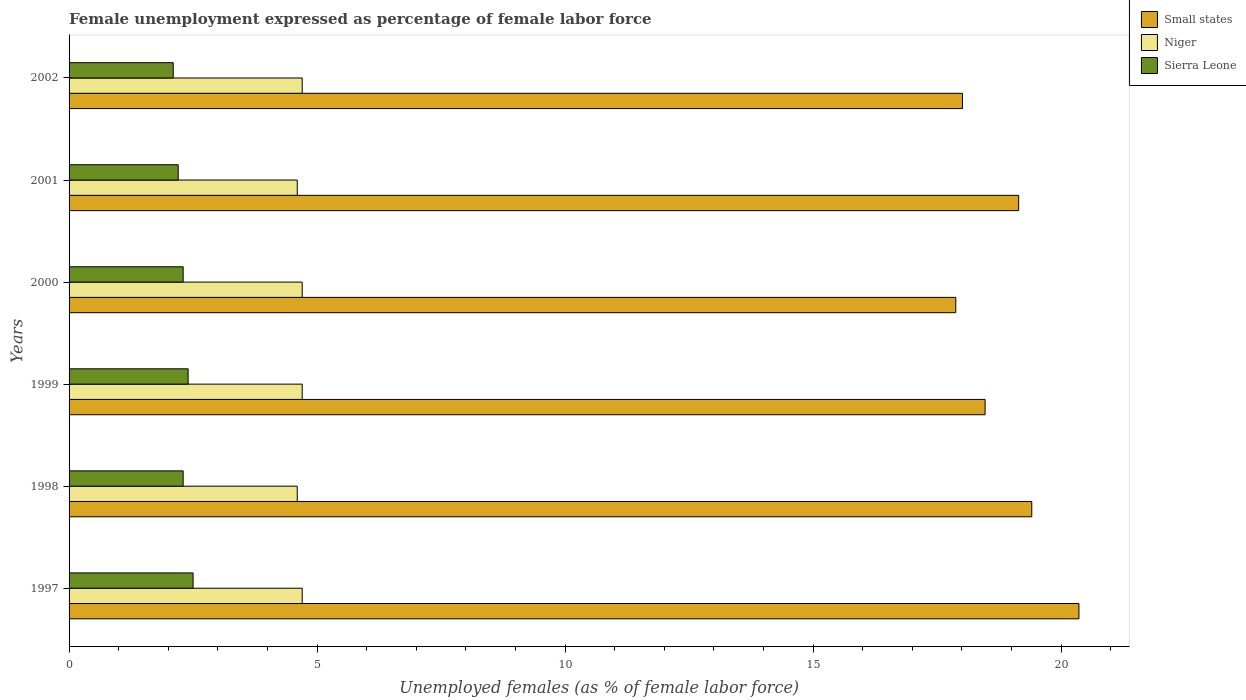How many different coloured bars are there?
Offer a very short reply. 3. Are the number of bars per tick equal to the number of legend labels?
Your answer should be very brief. Yes. How many bars are there on the 6th tick from the bottom?
Your answer should be compact. 3. What is the label of the 2nd group of bars from the top?
Make the answer very short. 2001. In how many cases, is the number of bars for a given year not equal to the number of legend labels?
Offer a terse response. 0. What is the unemployment in females in in Niger in 2000?
Give a very brief answer. 4.7. Across all years, what is the minimum unemployment in females in in Sierra Leone?
Make the answer very short. 2.1. In which year was the unemployment in females in in Niger minimum?
Ensure brevity in your answer.  1998. What is the total unemployment in females in in Small states in the graph?
Give a very brief answer. 113.26. What is the difference between the unemployment in females in in Small states in 1998 and that in 2001?
Provide a succinct answer. 0.26. What is the difference between the unemployment in females in in Niger in 1997 and the unemployment in females in in Small states in 2002?
Your response must be concise. -13.31. What is the average unemployment in females in in Small states per year?
Your answer should be compact. 18.88. In the year 1999, what is the difference between the unemployment in females in in Sierra Leone and unemployment in females in in Small states?
Your answer should be very brief. -16.07. In how many years, is the unemployment in females in in Niger greater than 15 %?
Offer a very short reply. 0. What is the ratio of the unemployment in females in in Small states in 1998 to that in 1999?
Your answer should be compact. 1.05. Is the unemployment in females in in Niger in 1998 less than that in 2002?
Ensure brevity in your answer.  Yes. What is the difference between the highest and the second highest unemployment in females in in Sierra Leone?
Offer a terse response. 0.1. What is the difference between the highest and the lowest unemployment in females in in Small states?
Offer a very short reply. 2.48. In how many years, is the unemployment in females in in Sierra Leone greater than the average unemployment in females in in Sierra Leone taken over all years?
Ensure brevity in your answer.  2. Is the sum of the unemployment in females in in Small states in 1997 and 2001 greater than the maximum unemployment in females in in Sierra Leone across all years?
Your answer should be very brief. Yes. What does the 1st bar from the top in 1998 represents?
Offer a terse response. Sierra Leone. What does the 1st bar from the bottom in 2000 represents?
Provide a succinct answer. Small states. How many bars are there?
Ensure brevity in your answer.  18. Are all the bars in the graph horizontal?
Provide a succinct answer. Yes. How many years are there in the graph?
Give a very brief answer. 6. Does the graph contain any zero values?
Your response must be concise. No. Where does the legend appear in the graph?
Your answer should be very brief. Top right. What is the title of the graph?
Ensure brevity in your answer.  Female unemployment expressed as percentage of female labor force. Does "Central Europe" appear as one of the legend labels in the graph?
Your answer should be compact. No. What is the label or title of the X-axis?
Provide a short and direct response. Unemployed females (as % of female labor force). What is the label or title of the Y-axis?
Ensure brevity in your answer.  Years. What is the Unemployed females (as % of female labor force) in Small states in 1997?
Offer a very short reply. 20.36. What is the Unemployed females (as % of female labor force) in Niger in 1997?
Keep it short and to the point. 4.7. What is the Unemployed females (as % of female labor force) of Sierra Leone in 1997?
Your answer should be very brief. 2.5. What is the Unemployed females (as % of female labor force) in Small states in 1998?
Give a very brief answer. 19.41. What is the Unemployed females (as % of female labor force) in Niger in 1998?
Provide a short and direct response. 4.6. What is the Unemployed females (as % of female labor force) of Sierra Leone in 1998?
Your answer should be compact. 2.3. What is the Unemployed females (as % of female labor force) in Small states in 1999?
Provide a succinct answer. 18.47. What is the Unemployed females (as % of female labor force) of Niger in 1999?
Your answer should be compact. 4.7. What is the Unemployed females (as % of female labor force) of Sierra Leone in 1999?
Ensure brevity in your answer.  2.4. What is the Unemployed females (as % of female labor force) in Small states in 2000?
Provide a short and direct response. 17.88. What is the Unemployed females (as % of female labor force) in Niger in 2000?
Keep it short and to the point. 4.7. What is the Unemployed females (as % of female labor force) in Sierra Leone in 2000?
Your answer should be compact. 2.3. What is the Unemployed females (as % of female labor force) of Small states in 2001?
Keep it short and to the point. 19.14. What is the Unemployed females (as % of female labor force) in Niger in 2001?
Your response must be concise. 4.6. What is the Unemployed females (as % of female labor force) in Sierra Leone in 2001?
Make the answer very short. 2.2. What is the Unemployed females (as % of female labor force) of Small states in 2002?
Ensure brevity in your answer.  18.01. What is the Unemployed females (as % of female labor force) of Niger in 2002?
Offer a terse response. 4.7. What is the Unemployed females (as % of female labor force) of Sierra Leone in 2002?
Your answer should be compact. 2.1. Across all years, what is the maximum Unemployed females (as % of female labor force) in Small states?
Offer a terse response. 20.36. Across all years, what is the maximum Unemployed females (as % of female labor force) in Niger?
Make the answer very short. 4.7. Across all years, what is the maximum Unemployed females (as % of female labor force) in Sierra Leone?
Provide a succinct answer. 2.5. Across all years, what is the minimum Unemployed females (as % of female labor force) of Small states?
Provide a succinct answer. 17.88. Across all years, what is the minimum Unemployed females (as % of female labor force) in Niger?
Give a very brief answer. 4.6. Across all years, what is the minimum Unemployed females (as % of female labor force) of Sierra Leone?
Offer a very short reply. 2.1. What is the total Unemployed females (as % of female labor force) of Small states in the graph?
Your response must be concise. 113.26. What is the total Unemployed females (as % of female labor force) of Niger in the graph?
Your answer should be very brief. 28. What is the total Unemployed females (as % of female labor force) of Sierra Leone in the graph?
Provide a succinct answer. 13.8. What is the difference between the Unemployed females (as % of female labor force) in Small states in 1997 and that in 1998?
Give a very brief answer. 0.95. What is the difference between the Unemployed females (as % of female labor force) of Sierra Leone in 1997 and that in 1998?
Keep it short and to the point. 0.2. What is the difference between the Unemployed females (as % of female labor force) in Small states in 1997 and that in 1999?
Give a very brief answer. 1.89. What is the difference between the Unemployed females (as % of female labor force) of Sierra Leone in 1997 and that in 1999?
Ensure brevity in your answer.  0.1. What is the difference between the Unemployed females (as % of female labor force) of Small states in 1997 and that in 2000?
Your response must be concise. 2.48. What is the difference between the Unemployed females (as % of female labor force) in Niger in 1997 and that in 2000?
Offer a terse response. 0. What is the difference between the Unemployed females (as % of female labor force) in Small states in 1997 and that in 2001?
Give a very brief answer. 1.22. What is the difference between the Unemployed females (as % of female labor force) of Niger in 1997 and that in 2001?
Keep it short and to the point. 0.1. What is the difference between the Unemployed females (as % of female labor force) in Sierra Leone in 1997 and that in 2001?
Your answer should be compact. 0.3. What is the difference between the Unemployed females (as % of female labor force) of Small states in 1997 and that in 2002?
Offer a terse response. 2.35. What is the difference between the Unemployed females (as % of female labor force) of Niger in 1997 and that in 2002?
Provide a short and direct response. 0. What is the difference between the Unemployed females (as % of female labor force) in Sierra Leone in 1997 and that in 2002?
Keep it short and to the point. 0.4. What is the difference between the Unemployed females (as % of female labor force) in Small states in 1998 and that in 1999?
Your response must be concise. 0.94. What is the difference between the Unemployed females (as % of female labor force) of Niger in 1998 and that in 1999?
Ensure brevity in your answer.  -0.1. What is the difference between the Unemployed females (as % of female labor force) in Sierra Leone in 1998 and that in 1999?
Offer a terse response. -0.1. What is the difference between the Unemployed females (as % of female labor force) in Small states in 1998 and that in 2000?
Offer a very short reply. 1.53. What is the difference between the Unemployed females (as % of female labor force) in Sierra Leone in 1998 and that in 2000?
Your answer should be very brief. 0. What is the difference between the Unemployed females (as % of female labor force) of Small states in 1998 and that in 2001?
Your answer should be compact. 0.26. What is the difference between the Unemployed females (as % of female labor force) in Niger in 1998 and that in 2001?
Keep it short and to the point. 0. What is the difference between the Unemployed females (as % of female labor force) of Small states in 1998 and that in 2002?
Offer a very short reply. 1.4. What is the difference between the Unemployed females (as % of female labor force) of Small states in 1999 and that in 2000?
Offer a terse response. 0.59. What is the difference between the Unemployed females (as % of female labor force) of Niger in 1999 and that in 2000?
Give a very brief answer. 0. What is the difference between the Unemployed females (as % of female labor force) of Sierra Leone in 1999 and that in 2000?
Ensure brevity in your answer.  0.1. What is the difference between the Unemployed females (as % of female labor force) of Small states in 1999 and that in 2001?
Ensure brevity in your answer.  -0.68. What is the difference between the Unemployed females (as % of female labor force) in Sierra Leone in 1999 and that in 2001?
Make the answer very short. 0.2. What is the difference between the Unemployed females (as % of female labor force) in Small states in 1999 and that in 2002?
Your answer should be very brief. 0.46. What is the difference between the Unemployed females (as % of female labor force) of Small states in 2000 and that in 2001?
Provide a short and direct response. -1.27. What is the difference between the Unemployed females (as % of female labor force) of Sierra Leone in 2000 and that in 2001?
Give a very brief answer. 0.1. What is the difference between the Unemployed females (as % of female labor force) in Small states in 2000 and that in 2002?
Keep it short and to the point. -0.14. What is the difference between the Unemployed females (as % of female labor force) in Sierra Leone in 2000 and that in 2002?
Your response must be concise. 0.2. What is the difference between the Unemployed females (as % of female labor force) in Small states in 2001 and that in 2002?
Your response must be concise. 1.13. What is the difference between the Unemployed females (as % of female labor force) in Sierra Leone in 2001 and that in 2002?
Give a very brief answer. 0.1. What is the difference between the Unemployed females (as % of female labor force) in Small states in 1997 and the Unemployed females (as % of female labor force) in Niger in 1998?
Give a very brief answer. 15.76. What is the difference between the Unemployed females (as % of female labor force) of Small states in 1997 and the Unemployed females (as % of female labor force) of Sierra Leone in 1998?
Provide a succinct answer. 18.06. What is the difference between the Unemployed females (as % of female labor force) of Small states in 1997 and the Unemployed females (as % of female labor force) of Niger in 1999?
Provide a succinct answer. 15.66. What is the difference between the Unemployed females (as % of female labor force) in Small states in 1997 and the Unemployed females (as % of female labor force) in Sierra Leone in 1999?
Your answer should be compact. 17.96. What is the difference between the Unemployed females (as % of female labor force) in Niger in 1997 and the Unemployed females (as % of female labor force) in Sierra Leone in 1999?
Your response must be concise. 2.3. What is the difference between the Unemployed females (as % of female labor force) of Small states in 1997 and the Unemployed females (as % of female labor force) of Niger in 2000?
Offer a terse response. 15.66. What is the difference between the Unemployed females (as % of female labor force) in Small states in 1997 and the Unemployed females (as % of female labor force) in Sierra Leone in 2000?
Provide a succinct answer. 18.06. What is the difference between the Unemployed females (as % of female labor force) of Niger in 1997 and the Unemployed females (as % of female labor force) of Sierra Leone in 2000?
Keep it short and to the point. 2.4. What is the difference between the Unemployed females (as % of female labor force) of Small states in 1997 and the Unemployed females (as % of female labor force) of Niger in 2001?
Your response must be concise. 15.76. What is the difference between the Unemployed females (as % of female labor force) in Small states in 1997 and the Unemployed females (as % of female labor force) in Sierra Leone in 2001?
Provide a short and direct response. 18.16. What is the difference between the Unemployed females (as % of female labor force) in Niger in 1997 and the Unemployed females (as % of female labor force) in Sierra Leone in 2001?
Provide a short and direct response. 2.5. What is the difference between the Unemployed females (as % of female labor force) in Small states in 1997 and the Unemployed females (as % of female labor force) in Niger in 2002?
Provide a succinct answer. 15.66. What is the difference between the Unemployed females (as % of female labor force) in Small states in 1997 and the Unemployed females (as % of female labor force) in Sierra Leone in 2002?
Give a very brief answer. 18.26. What is the difference between the Unemployed females (as % of female labor force) of Niger in 1997 and the Unemployed females (as % of female labor force) of Sierra Leone in 2002?
Your response must be concise. 2.6. What is the difference between the Unemployed females (as % of female labor force) in Small states in 1998 and the Unemployed females (as % of female labor force) in Niger in 1999?
Your answer should be compact. 14.71. What is the difference between the Unemployed females (as % of female labor force) of Small states in 1998 and the Unemployed females (as % of female labor force) of Sierra Leone in 1999?
Your answer should be compact. 17.01. What is the difference between the Unemployed females (as % of female labor force) of Niger in 1998 and the Unemployed females (as % of female labor force) of Sierra Leone in 1999?
Offer a very short reply. 2.2. What is the difference between the Unemployed females (as % of female labor force) in Small states in 1998 and the Unemployed females (as % of female labor force) in Niger in 2000?
Your response must be concise. 14.71. What is the difference between the Unemployed females (as % of female labor force) of Small states in 1998 and the Unemployed females (as % of female labor force) of Sierra Leone in 2000?
Make the answer very short. 17.11. What is the difference between the Unemployed females (as % of female labor force) of Small states in 1998 and the Unemployed females (as % of female labor force) of Niger in 2001?
Offer a terse response. 14.81. What is the difference between the Unemployed females (as % of female labor force) in Small states in 1998 and the Unemployed females (as % of female labor force) in Sierra Leone in 2001?
Your answer should be compact. 17.21. What is the difference between the Unemployed females (as % of female labor force) of Small states in 1998 and the Unemployed females (as % of female labor force) of Niger in 2002?
Your answer should be compact. 14.71. What is the difference between the Unemployed females (as % of female labor force) of Small states in 1998 and the Unemployed females (as % of female labor force) of Sierra Leone in 2002?
Your answer should be compact. 17.31. What is the difference between the Unemployed females (as % of female labor force) of Niger in 1998 and the Unemployed females (as % of female labor force) of Sierra Leone in 2002?
Give a very brief answer. 2.5. What is the difference between the Unemployed females (as % of female labor force) of Small states in 1999 and the Unemployed females (as % of female labor force) of Niger in 2000?
Ensure brevity in your answer.  13.77. What is the difference between the Unemployed females (as % of female labor force) in Small states in 1999 and the Unemployed females (as % of female labor force) in Sierra Leone in 2000?
Make the answer very short. 16.17. What is the difference between the Unemployed females (as % of female labor force) in Niger in 1999 and the Unemployed females (as % of female labor force) in Sierra Leone in 2000?
Provide a succinct answer. 2.4. What is the difference between the Unemployed females (as % of female labor force) in Small states in 1999 and the Unemployed females (as % of female labor force) in Niger in 2001?
Ensure brevity in your answer.  13.87. What is the difference between the Unemployed females (as % of female labor force) in Small states in 1999 and the Unemployed females (as % of female labor force) in Sierra Leone in 2001?
Your response must be concise. 16.27. What is the difference between the Unemployed females (as % of female labor force) in Small states in 1999 and the Unemployed females (as % of female labor force) in Niger in 2002?
Your answer should be compact. 13.77. What is the difference between the Unemployed females (as % of female labor force) in Small states in 1999 and the Unemployed females (as % of female labor force) in Sierra Leone in 2002?
Ensure brevity in your answer.  16.37. What is the difference between the Unemployed females (as % of female labor force) of Small states in 2000 and the Unemployed females (as % of female labor force) of Niger in 2001?
Make the answer very short. 13.28. What is the difference between the Unemployed females (as % of female labor force) in Small states in 2000 and the Unemployed females (as % of female labor force) in Sierra Leone in 2001?
Offer a terse response. 15.68. What is the difference between the Unemployed females (as % of female labor force) of Niger in 2000 and the Unemployed females (as % of female labor force) of Sierra Leone in 2001?
Keep it short and to the point. 2.5. What is the difference between the Unemployed females (as % of female labor force) in Small states in 2000 and the Unemployed females (as % of female labor force) in Niger in 2002?
Offer a very short reply. 13.18. What is the difference between the Unemployed females (as % of female labor force) of Small states in 2000 and the Unemployed females (as % of female labor force) of Sierra Leone in 2002?
Your answer should be compact. 15.78. What is the difference between the Unemployed females (as % of female labor force) in Niger in 2000 and the Unemployed females (as % of female labor force) in Sierra Leone in 2002?
Ensure brevity in your answer.  2.6. What is the difference between the Unemployed females (as % of female labor force) in Small states in 2001 and the Unemployed females (as % of female labor force) in Niger in 2002?
Provide a short and direct response. 14.44. What is the difference between the Unemployed females (as % of female labor force) of Small states in 2001 and the Unemployed females (as % of female labor force) of Sierra Leone in 2002?
Provide a short and direct response. 17.04. What is the difference between the Unemployed females (as % of female labor force) in Niger in 2001 and the Unemployed females (as % of female labor force) in Sierra Leone in 2002?
Ensure brevity in your answer.  2.5. What is the average Unemployed females (as % of female labor force) of Small states per year?
Your response must be concise. 18.88. What is the average Unemployed females (as % of female labor force) in Niger per year?
Your response must be concise. 4.67. In the year 1997, what is the difference between the Unemployed females (as % of female labor force) of Small states and Unemployed females (as % of female labor force) of Niger?
Offer a terse response. 15.66. In the year 1997, what is the difference between the Unemployed females (as % of female labor force) of Small states and Unemployed females (as % of female labor force) of Sierra Leone?
Make the answer very short. 17.86. In the year 1998, what is the difference between the Unemployed females (as % of female labor force) in Small states and Unemployed females (as % of female labor force) in Niger?
Your answer should be compact. 14.81. In the year 1998, what is the difference between the Unemployed females (as % of female labor force) of Small states and Unemployed females (as % of female labor force) of Sierra Leone?
Your answer should be very brief. 17.11. In the year 1999, what is the difference between the Unemployed females (as % of female labor force) of Small states and Unemployed females (as % of female labor force) of Niger?
Your answer should be very brief. 13.77. In the year 1999, what is the difference between the Unemployed females (as % of female labor force) in Small states and Unemployed females (as % of female labor force) in Sierra Leone?
Offer a terse response. 16.07. In the year 1999, what is the difference between the Unemployed females (as % of female labor force) of Niger and Unemployed females (as % of female labor force) of Sierra Leone?
Provide a succinct answer. 2.3. In the year 2000, what is the difference between the Unemployed females (as % of female labor force) of Small states and Unemployed females (as % of female labor force) of Niger?
Your answer should be very brief. 13.18. In the year 2000, what is the difference between the Unemployed females (as % of female labor force) in Small states and Unemployed females (as % of female labor force) in Sierra Leone?
Offer a terse response. 15.58. In the year 2001, what is the difference between the Unemployed females (as % of female labor force) in Small states and Unemployed females (as % of female labor force) in Niger?
Offer a very short reply. 14.54. In the year 2001, what is the difference between the Unemployed females (as % of female labor force) in Small states and Unemployed females (as % of female labor force) in Sierra Leone?
Your answer should be compact. 16.94. In the year 2002, what is the difference between the Unemployed females (as % of female labor force) of Small states and Unemployed females (as % of female labor force) of Niger?
Offer a terse response. 13.31. In the year 2002, what is the difference between the Unemployed females (as % of female labor force) in Small states and Unemployed females (as % of female labor force) in Sierra Leone?
Provide a short and direct response. 15.91. What is the ratio of the Unemployed females (as % of female labor force) of Small states in 1997 to that in 1998?
Give a very brief answer. 1.05. What is the ratio of the Unemployed females (as % of female labor force) in Niger in 1997 to that in 1998?
Make the answer very short. 1.02. What is the ratio of the Unemployed females (as % of female labor force) in Sierra Leone in 1997 to that in 1998?
Keep it short and to the point. 1.09. What is the ratio of the Unemployed females (as % of female labor force) in Small states in 1997 to that in 1999?
Keep it short and to the point. 1.1. What is the ratio of the Unemployed females (as % of female labor force) of Niger in 1997 to that in 1999?
Give a very brief answer. 1. What is the ratio of the Unemployed females (as % of female labor force) in Sierra Leone in 1997 to that in 1999?
Your answer should be compact. 1.04. What is the ratio of the Unemployed females (as % of female labor force) of Small states in 1997 to that in 2000?
Keep it short and to the point. 1.14. What is the ratio of the Unemployed females (as % of female labor force) of Niger in 1997 to that in 2000?
Provide a short and direct response. 1. What is the ratio of the Unemployed females (as % of female labor force) in Sierra Leone in 1997 to that in 2000?
Provide a succinct answer. 1.09. What is the ratio of the Unemployed females (as % of female labor force) of Small states in 1997 to that in 2001?
Provide a short and direct response. 1.06. What is the ratio of the Unemployed females (as % of female labor force) in Niger in 1997 to that in 2001?
Give a very brief answer. 1.02. What is the ratio of the Unemployed females (as % of female labor force) of Sierra Leone in 1997 to that in 2001?
Your answer should be very brief. 1.14. What is the ratio of the Unemployed females (as % of female labor force) in Small states in 1997 to that in 2002?
Make the answer very short. 1.13. What is the ratio of the Unemployed females (as % of female labor force) in Niger in 1997 to that in 2002?
Make the answer very short. 1. What is the ratio of the Unemployed females (as % of female labor force) in Sierra Leone in 1997 to that in 2002?
Ensure brevity in your answer.  1.19. What is the ratio of the Unemployed females (as % of female labor force) of Small states in 1998 to that in 1999?
Your answer should be very brief. 1.05. What is the ratio of the Unemployed females (as % of female labor force) in Niger in 1998 to that in 1999?
Ensure brevity in your answer.  0.98. What is the ratio of the Unemployed females (as % of female labor force) of Small states in 1998 to that in 2000?
Provide a succinct answer. 1.09. What is the ratio of the Unemployed females (as % of female labor force) of Niger in 1998 to that in 2000?
Provide a short and direct response. 0.98. What is the ratio of the Unemployed females (as % of female labor force) of Sierra Leone in 1998 to that in 2000?
Make the answer very short. 1. What is the ratio of the Unemployed females (as % of female labor force) in Small states in 1998 to that in 2001?
Your response must be concise. 1.01. What is the ratio of the Unemployed females (as % of female labor force) of Niger in 1998 to that in 2001?
Provide a short and direct response. 1. What is the ratio of the Unemployed females (as % of female labor force) of Sierra Leone in 1998 to that in 2001?
Make the answer very short. 1.05. What is the ratio of the Unemployed females (as % of female labor force) of Small states in 1998 to that in 2002?
Ensure brevity in your answer.  1.08. What is the ratio of the Unemployed females (as % of female labor force) in Niger in 1998 to that in 2002?
Provide a succinct answer. 0.98. What is the ratio of the Unemployed females (as % of female labor force) of Sierra Leone in 1998 to that in 2002?
Give a very brief answer. 1.1. What is the ratio of the Unemployed females (as % of female labor force) of Small states in 1999 to that in 2000?
Offer a very short reply. 1.03. What is the ratio of the Unemployed females (as % of female labor force) of Sierra Leone in 1999 to that in 2000?
Your answer should be very brief. 1.04. What is the ratio of the Unemployed females (as % of female labor force) of Small states in 1999 to that in 2001?
Offer a very short reply. 0.96. What is the ratio of the Unemployed females (as % of female labor force) in Niger in 1999 to that in 2001?
Give a very brief answer. 1.02. What is the ratio of the Unemployed females (as % of female labor force) of Sierra Leone in 1999 to that in 2001?
Provide a succinct answer. 1.09. What is the ratio of the Unemployed females (as % of female labor force) in Small states in 1999 to that in 2002?
Your response must be concise. 1.03. What is the ratio of the Unemployed females (as % of female labor force) in Niger in 1999 to that in 2002?
Ensure brevity in your answer.  1. What is the ratio of the Unemployed females (as % of female labor force) in Sierra Leone in 1999 to that in 2002?
Provide a succinct answer. 1.14. What is the ratio of the Unemployed females (as % of female labor force) of Small states in 2000 to that in 2001?
Ensure brevity in your answer.  0.93. What is the ratio of the Unemployed females (as % of female labor force) in Niger in 2000 to that in 2001?
Offer a very short reply. 1.02. What is the ratio of the Unemployed females (as % of female labor force) of Sierra Leone in 2000 to that in 2001?
Your answer should be compact. 1.05. What is the ratio of the Unemployed females (as % of female labor force) in Niger in 2000 to that in 2002?
Provide a short and direct response. 1. What is the ratio of the Unemployed females (as % of female labor force) in Sierra Leone in 2000 to that in 2002?
Give a very brief answer. 1.1. What is the ratio of the Unemployed females (as % of female labor force) of Small states in 2001 to that in 2002?
Offer a terse response. 1.06. What is the ratio of the Unemployed females (as % of female labor force) of Niger in 2001 to that in 2002?
Your response must be concise. 0.98. What is the ratio of the Unemployed females (as % of female labor force) in Sierra Leone in 2001 to that in 2002?
Offer a terse response. 1.05. What is the difference between the highest and the second highest Unemployed females (as % of female labor force) of Small states?
Keep it short and to the point. 0.95. What is the difference between the highest and the lowest Unemployed females (as % of female labor force) of Small states?
Make the answer very short. 2.48. 